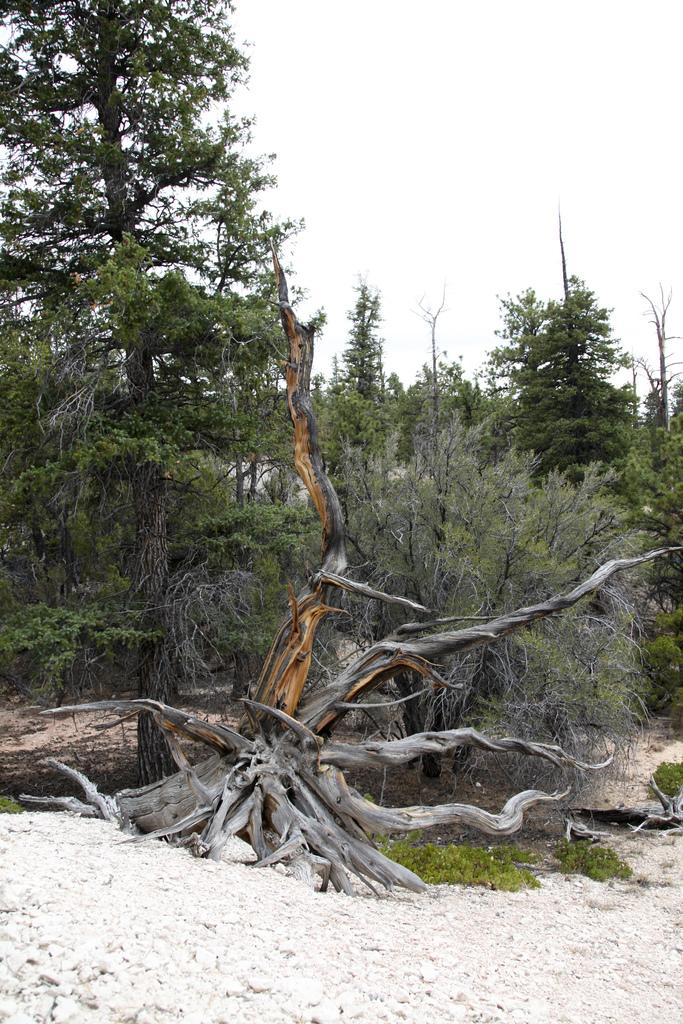What type of vegetation can be seen in the image? There are trees in the image. What type of ground cover is present in the image? There is grass in the image. Where is the faucet located in the image? There is no faucet present in the image. What type of surprise can be seen in the image? There is no surprise present in the image; it features trees and grass. 